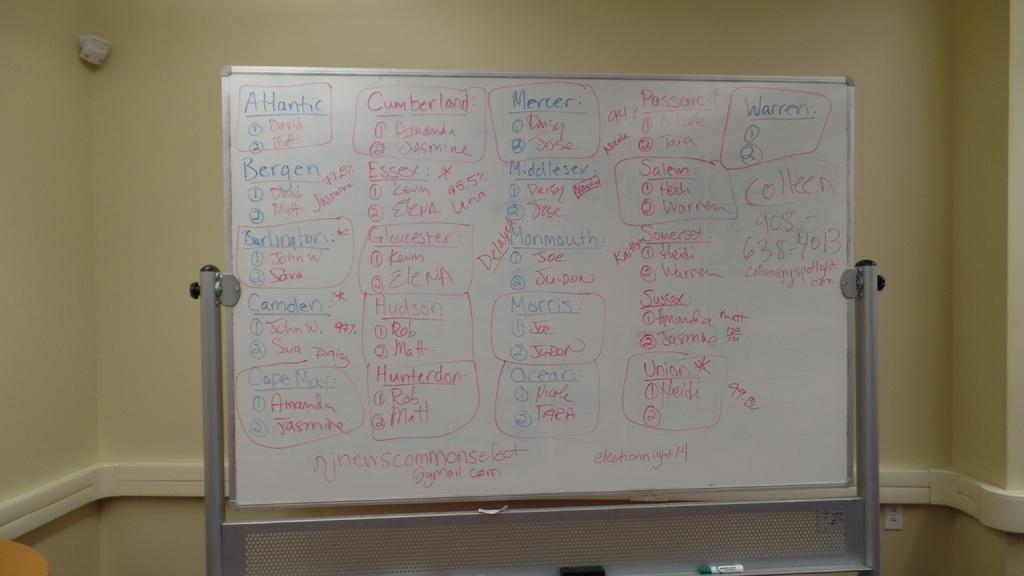<image>
Write a terse but informative summary of the picture. White board with words on it showing "Atlantic" on the top left. 